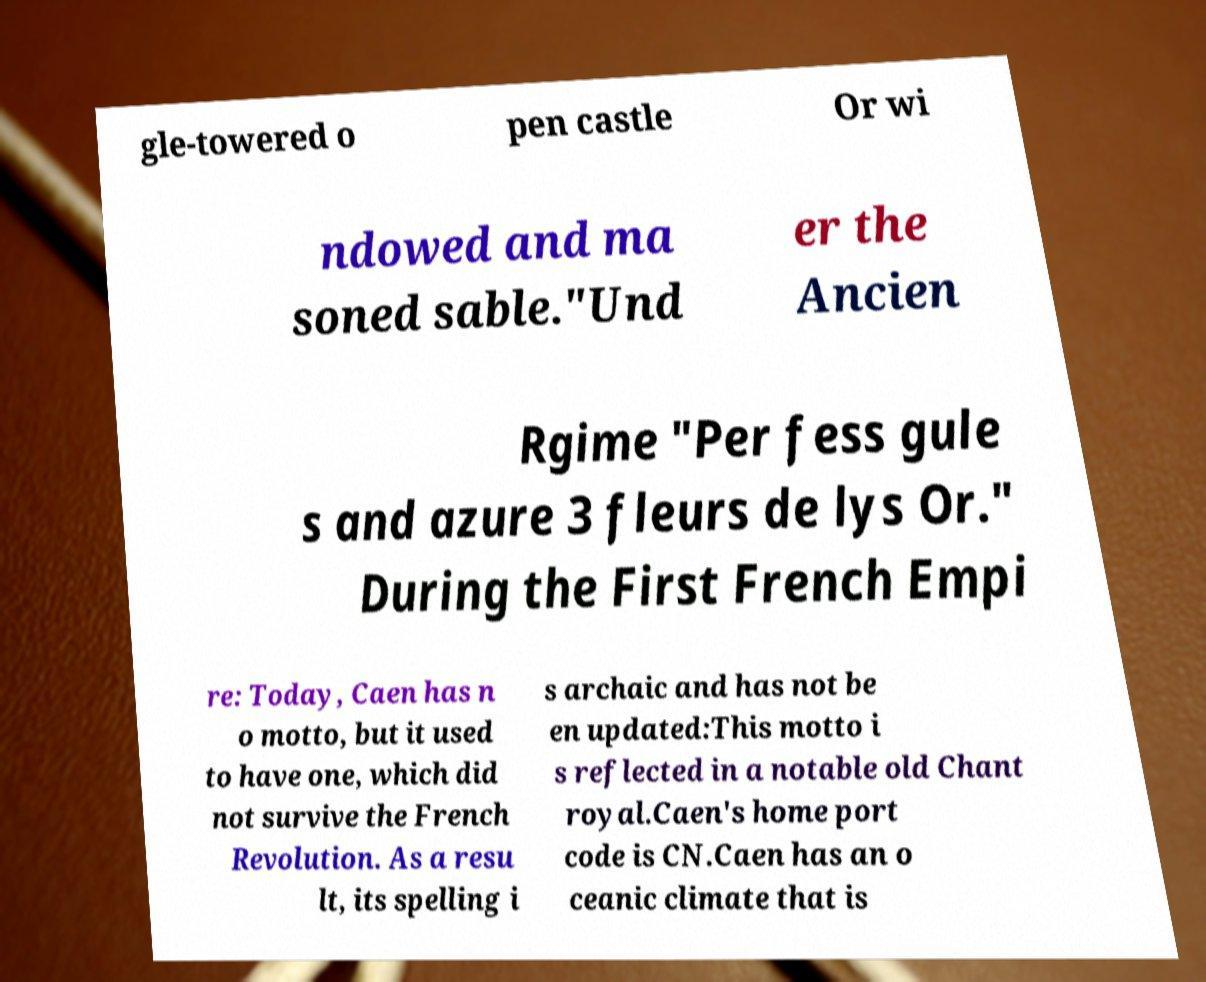Can you read and provide the text displayed in the image?This photo seems to have some interesting text. Can you extract and type it out for me? gle-towered o pen castle Or wi ndowed and ma soned sable."Und er the Ancien Rgime "Per fess gule s and azure 3 fleurs de lys Or." During the First French Empi re: Today, Caen has n o motto, but it used to have one, which did not survive the French Revolution. As a resu lt, its spelling i s archaic and has not be en updated:This motto i s reflected in a notable old Chant royal.Caen's home port code is CN.Caen has an o ceanic climate that is 